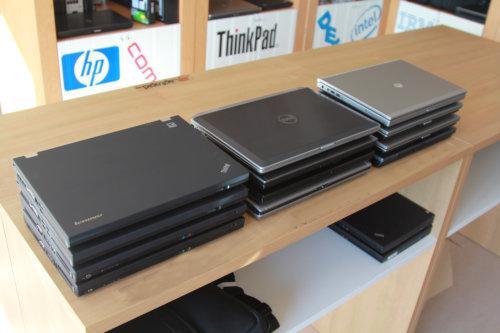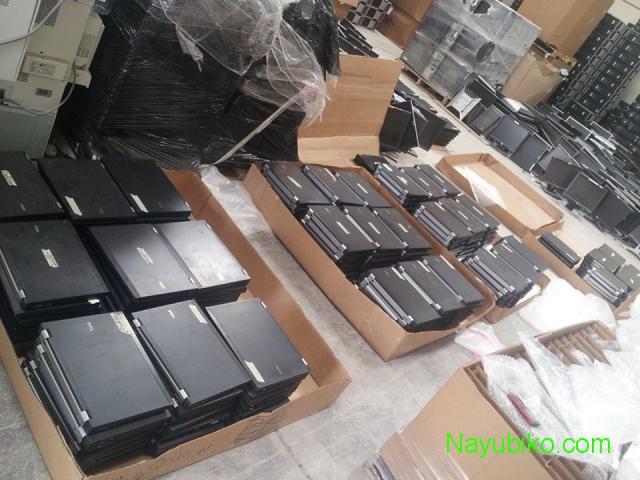The first image is the image on the left, the second image is the image on the right. Analyze the images presented: Is the assertion "In the image to the left, the electronics are in boxes." valid? Answer yes or no. No. 